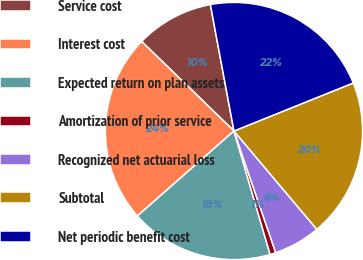Convert chart to OTSL. <chart><loc_0><loc_0><loc_500><loc_500><pie_chart><fcel>Service cost<fcel>Interest cost<fcel>Expected return on plan assets<fcel>Amortization of prior service<fcel>Recognized net actuarial loss<fcel>Subtotal<fcel>Net periodic benefit cost<nl><fcel>9.81%<fcel>23.74%<fcel>18.05%<fcel>0.73%<fcel>5.88%<fcel>19.95%<fcel>21.84%<nl></chart> 